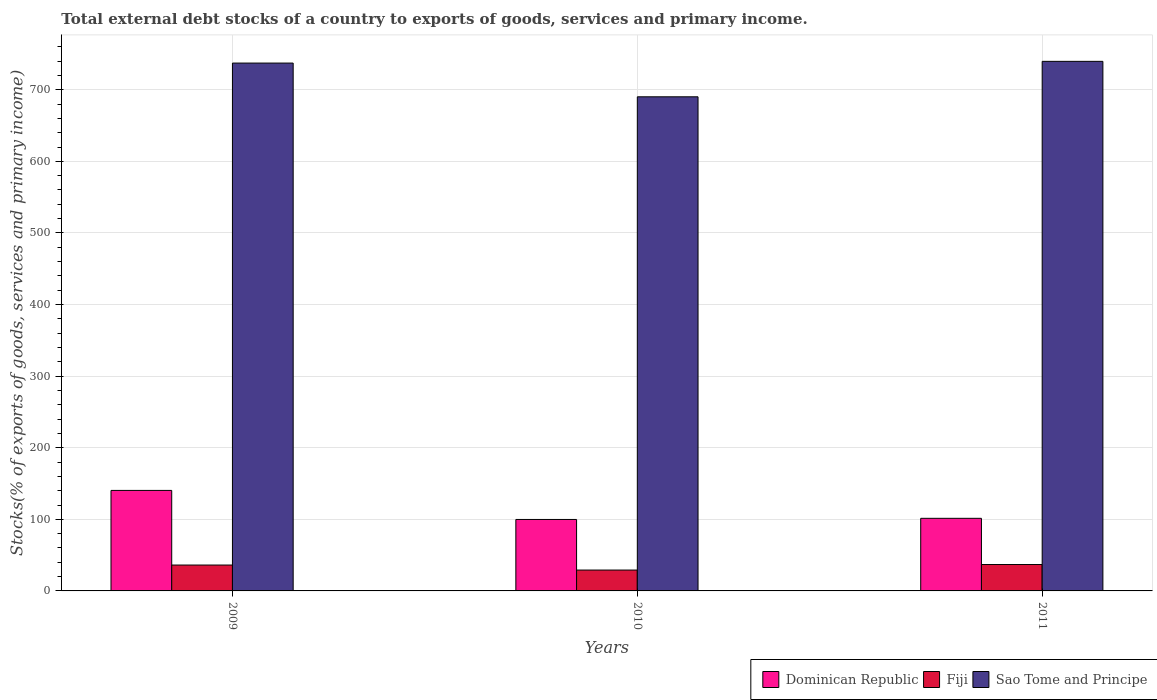Are the number of bars on each tick of the X-axis equal?
Ensure brevity in your answer.  Yes. How many bars are there on the 3rd tick from the left?
Provide a succinct answer. 3. In how many cases, is the number of bars for a given year not equal to the number of legend labels?
Offer a very short reply. 0. What is the total debt stocks in Dominican Republic in 2009?
Offer a very short reply. 140.39. Across all years, what is the maximum total debt stocks in Dominican Republic?
Your answer should be compact. 140.39. Across all years, what is the minimum total debt stocks in Dominican Republic?
Your answer should be compact. 99.8. In which year was the total debt stocks in Dominican Republic minimum?
Your answer should be compact. 2010. What is the total total debt stocks in Sao Tome and Principe in the graph?
Make the answer very short. 2167.05. What is the difference between the total debt stocks in Dominican Republic in 2009 and that in 2010?
Provide a short and direct response. 40.59. What is the difference between the total debt stocks in Sao Tome and Principe in 2010 and the total debt stocks in Fiji in 2009?
Provide a succinct answer. 654. What is the average total debt stocks in Sao Tome and Principe per year?
Your response must be concise. 722.35. In the year 2011, what is the difference between the total debt stocks in Sao Tome and Principe and total debt stocks in Dominican Republic?
Keep it short and to the point. 638.25. What is the ratio of the total debt stocks in Dominican Republic in 2009 to that in 2010?
Offer a terse response. 1.41. What is the difference between the highest and the second highest total debt stocks in Sao Tome and Principe?
Offer a terse response. 2.4. What is the difference between the highest and the lowest total debt stocks in Dominican Republic?
Keep it short and to the point. 40.59. What does the 2nd bar from the left in 2009 represents?
Give a very brief answer. Fiji. What does the 2nd bar from the right in 2011 represents?
Your answer should be very brief. Fiji. What is the difference between two consecutive major ticks on the Y-axis?
Keep it short and to the point. 100. Does the graph contain any zero values?
Offer a very short reply. No. How many legend labels are there?
Your answer should be compact. 3. What is the title of the graph?
Your answer should be very brief. Total external debt stocks of a country to exports of goods, services and primary income. Does "Liberia" appear as one of the legend labels in the graph?
Give a very brief answer. No. What is the label or title of the Y-axis?
Keep it short and to the point. Stocks(% of exports of goods, services and primary income). What is the Stocks(% of exports of goods, services and primary income) in Dominican Republic in 2009?
Your answer should be compact. 140.39. What is the Stocks(% of exports of goods, services and primary income) of Fiji in 2009?
Provide a succinct answer. 36.14. What is the Stocks(% of exports of goods, services and primary income) in Sao Tome and Principe in 2009?
Make the answer very short. 737.25. What is the Stocks(% of exports of goods, services and primary income) in Dominican Republic in 2010?
Your response must be concise. 99.8. What is the Stocks(% of exports of goods, services and primary income) of Fiji in 2010?
Offer a terse response. 29.14. What is the Stocks(% of exports of goods, services and primary income) in Sao Tome and Principe in 2010?
Provide a short and direct response. 690.15. What is the Stocks(% of exports of goods, services and primary income) of Dominican Republic in 2011?
Keep it short and to the point. 101.4. What is the Stocks(% of exports of goods, services and primary income) of Fiji in 2011?
Offer a terse response. 36.88. What is the Stocks(% of exports of goods, services and primary income) in Sao Tome and Principe in 2011?
Provide a short and direct response. 739.65. Across all years, what is the maximum Stocks(% of exports of goods, services and primary income) in Dominican Republic?
Your answer should be very brief. 140.39. Across all years, what is the maximum Stocks(% of exports of goods, services and primary income) of Fiji?
Give a very brief answer. 36.88. Across all years, what is the maximum Stocks(% of exports of goods, services and primary income) of Sao Tome and Principe?
Give a very brief answer. 739.65. Across all years, what is the minimum Stocks(% of exports of goods, services and primary income) in Dominican Republic?
Offer a terse response. 99.8. Across all years, what is the minimum Stocks(% of exports of goods, services and primary income) of Fiji?
Give a very brief answer. 29.14. Across all years, what is the minimum Stocks(% of exports of goods, services and primary income) of Sao Tome and Principe?
Provide a short and direct response. 690.15. What is the total Stocks(% of exports of goods, services and primary income) in Dominican Republic in the graph?
Give a very brief answer. 341.59. What is the total Stocks(% of exports of goods, services and primary income) in Fiji in the graph?
Offer a terse response. 102.17. What is the total Stocks(% of exports of goods, services and primary income) of Sao Tome and Principe in the graph?
Give a very brief answer. 2167.05. What is the difference between the Stocks(% of exports of goods, services and primary income) of Dominican Republic in 2009 and that in 2010?
Offer a very short reply. 40.59. What is the difference between the Stocks(% of exports of goods, services and primary income) in Fiji in 2009 and that in 2010?
Your response must be concise. 7. What is the difference between the Stocks(% of exports of goods, services and primary income) in Sao Tome and Principe in 2009 and that in 2010?
Provide a short and direct response. 47.11. What is the difference between the Stocks(% of exports of goods, services and primary income) in Dominican Republic in 2009 and that in 2011?
Your response must be concise. 38.99. What is the difference between the Stocks(% of exports of goods, services and primary income) of Fiji in 2009 and that in 2011?
Keep it short and to the point. -0.74. What is the difference between the Stocks(% of exports of goods, services and primary income) of Sao Tome and Principe in 2009 and that in 2011?
Your answer should be very brief. -2.4. What is the difference between the Stocks(% of exports of goods, services and primary income) of Dominican Republic in 2010 and that in 2011?
Keep it short and to the point. -1.6. What is the difference between the Stocks(% of exports of goods, services and primary income) of Fiji in 2010 and that in 2011?
Give a very brief answer. -7.74. What is the difference between the Stocks(% of exports of goods, services and primary income) of Sao Tome and Principe in 2010 and that in 2011?
Keep it short and to the point. -49.51. What is the difference between the Stocks(% of exports of goods, services and primary income) of Dominican Republic in 2009 and the Stocks(% of exports of goods, services and primary income) of Fiji in 2010?
Offer a terse response. 111.25. What is the difference between the Stocks(% of exports of goods, services and primary income) in Dominican Republic in 2009 and the Stocks(% of exports of goods, services and primary income) in Sao Tome and Principe in 2010?
Your answer should be very brief. -549.75. What is the difference between the Stocks(% of exports of goods, services and primary income) of Fiji in 2009 and the Stocks(% of exports of goods, services and primary income) of Sao Tome and Principe in 2010?
Your answer should be very brief. -654. What is the difference between the Stocks(% of exports of goods, services and primary income) in Dominican Republic in 2009 and the Stocks(% of exports of goods, services and primary income) in Fiji in 2011?
Your answer should be very brief. 103.51. What is the difference between the Stocks(% of exports of goods, services and primary income) of Dominican Republic in 2009 and the Stocks(% of exports of goods, services and primary income) of Sao Tome and Principe in 2011?
Ensure brevity in your answer.  -599.26. What is the difference between the Stocks(% of exports of goods, services and primary income) of Fiji in 2009 and the Stocks(% of exports of goods, services and primary income) of Sao Tome and Principe in 2011?
Give a very brief answer. -703.51. What is the difference between the Stocks(% of exports of goods, services and primary income) in Dominican Republic in 2010 and the Stocks(% of exports of goods, services and primary income) in Fiji in 2011?
Keep it short and to the point. 62.92. What is the difference between the Stocks(% of exports of goods, services and primary income) of Dominican Republic in 2010 and the Stocks(% of exports of goods, services and primary income) of Sao Tome and Principe in 2011?
Provide a short and direct response. -639.85. What is the difference between the Stocks(% of exports of goods, services and primary income) of Fiji in 2010 and the Stocks(% of exports of goods, services and primary income) of Sao Tome and Principe in 2011?
Offer a terse response. -710.51. What is the average Stocks(% of exports of goods, services and primary income) in Dominican Republic per year?
Provide a succinct answer. 113.86. What is the average Stocks(% of exports of goods, services and primary income) in Fiji per year?
Make the answer very short. 34.06. What is the average Stocks(% of exports of goods, services and primary income) in Sao Tome and Principe per year?
Give a very brief answer. 722.35. In the year 2009, what is the difference between the Stocks(% of exports of goods, services and primary income) of Dominican Republic and Stocks(% of exports of goods, services and primary income) of Fiji?
Provide a succinct answer. 104.25. In the year 2009, what is the difference between the Stocks(% of exports of goods, services and primary income) of Dominican Republic and Stocks(% of exports of goods, services and primary income) of Sao Tome and Principe?
Your answer should be compact. -596.86. In the year 2009, what is the difference between the Stocks(% of exports of goods, services and primary income) in Fiji and Stocks(% of exports of goods, services and primary income) in Sao Tome and Principe?
Your answer should be very brief. -701.11. In the year 2010, what is the difference between the Stocks(% of exports of goods, services and primary income) in Dominican Republic and Stocks(% of exports of goods, services and primary income) in Fiji?
Make the answer very short. 70.66. In the year 2010, what is the difference between the Stocks(% of exports of goods, services and primary income) of Dominican Republic and Stocks(% of exports of goods, services and primary income) of Sao Tome and Principe?
Your answer should be compact. -590.34. In the year 2010, what is the difference between the Stocks(% of exports of goods, services and primary income) in Fiji and Stocks(% of exports of goods, services and primary income) in Sao Tome and Principe?
Give a very brief answer. -661. In the year 2011, what is the difference between the Stocks(% of exports of goods, services and primary income) in Dominican Republic and Stocks(% of exports of goods, services and primary income) in Fiji?
Keep it short and to the point. 64.52. In the year 2011, what is the difference between the Stocks(% of exports of goods, services and primary income) of Dominican Republic and Stocks(% of exports of goods, services and primary income) of Sao Tome and Principe?
Provide a short and direct response. -638.25. In the year 2011, what is the difference between the Stocks(% of exports of goods, services and primary income) of Fiji and Stocks(% of exports of goods, services and primary income) of Sao Tome and Principe?
Your answer should be very brief. -702.77. What is the ratio of the Stocks(% of exports of goods, services and primary income) of Dominican Republic in 2009 to that in 2010?
Your answer should be very brief. 1.41. What is the ratio of the Stocks(% of exports of goods, services and primary income) of Fiji in 2009 to that in 2010?
Your answer should be compact. 1.24. What is the ratio of the Stocks(% of exports of goods, services and primary income) of Sao Tome and Principe in 2009 to that in 2010?
Provide a short and direct response. 1.07. What is the ratio of the Stocks(% of exports of goods, services and primary income) of Dominican Republic in 2009 to that in 2011?
Your answer should be very brief. 1.38. What is the ratio of the Stocks(% of exports of goods, services and primary income) in Fiji in 2009 to that in 2011?
Offer a terse response. 0.98. What is the ratio of the Stocks(% of exports of goods, services and primary income) in Sao Tome and Principe in 2009 to that in 2011?
Make the answer very short. 1. What is the ratio of the Stocks(% of exports of goods, services and primary income) in Dominican Republic in 2010 to that in 2011?
Keep it short and to the point. 0.98. What is the ratio of the Stocks(% of exports of goods, services and primary income) of Fiji in 2010 to that in 2011?
Provide a short and direct response. 0.79. What is the ratio of the Stocks(% of exports of goods, services and primary income) in Sao Tome and Principe in 2010 to that in 2011?
Provide a succinct answer. 0.93. What is the difference between the highest and the second highest Stocks(% of exports of goods, services and primary income) in Dominican Republic?
Make the answer very short. 38.99. What is the difference between the highest and the second highest Stocks(% of exports of goods, services and primary income) of Fiji?
Provide a succinct answer. 0.74. What is the difference between the highest and the second highest Stocks(% of exports of goods, services and primary income) of Sao Tome and Principe?
Your response must be concise. 2.4. What is the difference between the highest and the lowest Stocks(% of exports of goods, services and primary income) in Dominican Republic?
Offer a very short reply. 40.59. What is the difference between the highest and the lowest Stocks(% of exports of goods, services and primary income) in Fiji?
Ensure brevity in your answer.  7.74. What is the difference between the highest and the lowest Stocks(% of exports of goods, services and primary income) of Sao Tome and Principe?
Ensure brevity in your answer.  49.51. 